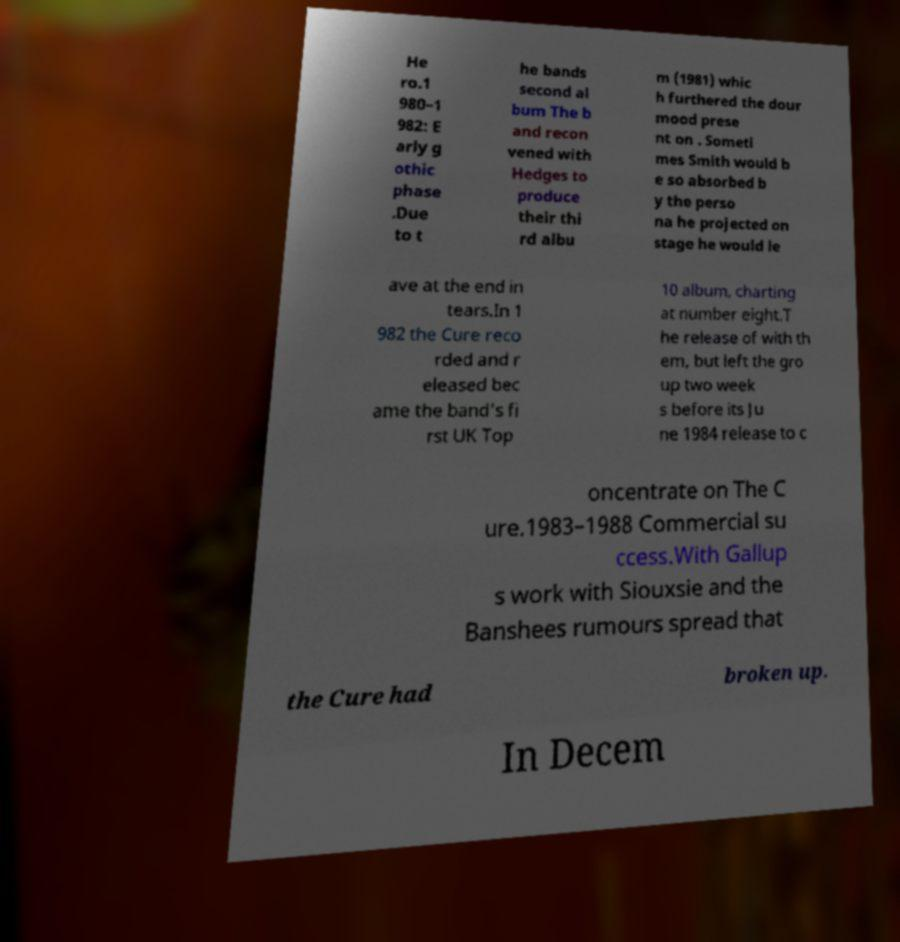Can you accurately transcribe the text from the provided image for me? He ro.1 980–1 982: E arly g othic phase .Due to t he bands second al bum The b and recon vened with Hedges to produce their thi rd albu m (1981) whic h furthered the dour mood prese nt on . Someti mes Smith would b e so absorbed b y the perso na he projected on stage he would le ave at the end in tears.In 1 982 the Cure reco rded and r eleased bec ame the band's fi rst UK Top 10 album, charting at number eight.T he release of with th em, but left the gro up two week s before its Ju ne 1984 release to c oncentrate on The C ure.1983–1988 Commercial su ccess.With Gallup s work with Siouxsie and the Banshees rumours spread that the Cure had broken up. In Decem 